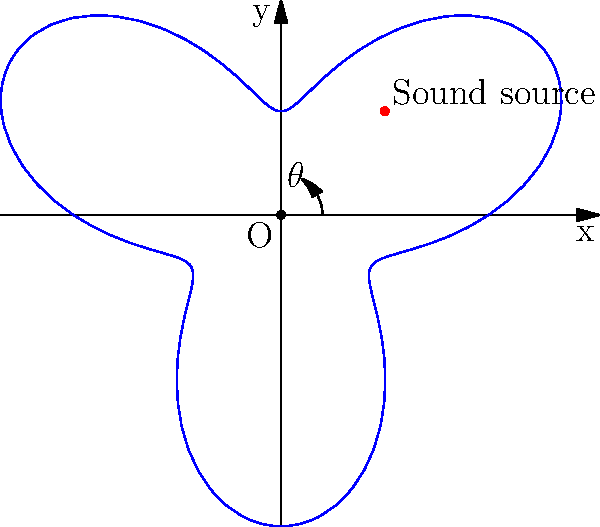In our groundbreaking investigation of sound wave propagation using polar coordinates, we've mapped the intensity of a unique sound source. The polar equation $r = 1 + 0.5\sin(3\theta)$ represents the sound intensity at different angles. What's the maximum number of lobes (areas of high intensity) in this pattern, and how might this inform our understanding of innovative acoustic design? To determine the number of lobes in this sound intensity pattern, we need to analyze the polar equation $r = 1 + 0.5\sin(3\theta)$. Here's a step-by-step approach:

1) The sinusoidal term $0.5\sin(3\theta)$ is key to understanding the pattern's shape.

2) The factor of 3 inside the sine function ($\sin(3\theta)$) indicates that the pattern repeats 3 times as $\theta$ goes from 0 to $2\pi$.

3) Each complete cycle of the sine function corresponds to two lobes: one where the sine is positive (extending the radius beyond 1) and one where it's negative (reducing the radius below 1).

4) Since there are 3 complete cycles as $\theta$ goes from 0 to $2\pi$, there will be $3 \times 2 = 6$ lobes in total.

5) This hexagonal-like pattern suggests that the sound source emits energy more strongly in six specific directions.

6) In innovative acoustic design, this could be used to create directional speakers or to design rooms with unique sound reflection properties. For instance, a concert hall could be designed to enhance sound projection in these six directions, creating an immersive audio experience.

7) Understanding these patterns could also lead to breakthroughs in noise cancellation technology, where we could potentially design systems to counteract specific sound propagation patterns.

This analysis demonstrates how polar coordinates can reveal complex patterns in sound propagation, opening up new possibilities for acoustic engineering and sound design.
Answer: 6 lobes 